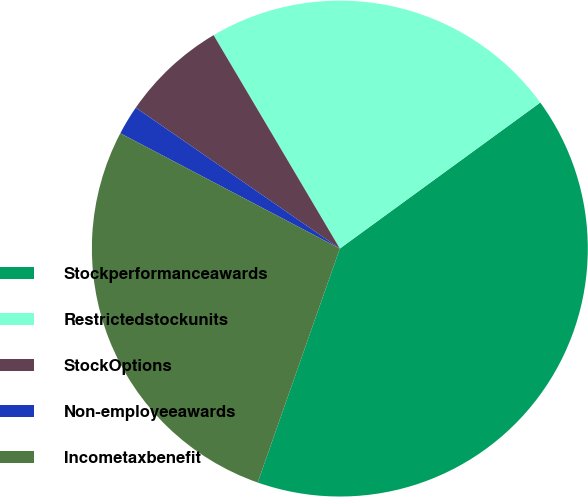Convert chart to OTSL. <chart><loc_0><loc_0><loc_500><loc_500><pie_chart><fcel>Stockperformanceawards<fcel>Restrictedstockunits<fcel>StockOptions<fcel>Non-employeeawards<fcel>Incometaxbenefit<nl><fcel>40.39%<fcel>23.48%<fcel>6.88%<fcel>1.92%<fcel>27.32%<nl></chart> 